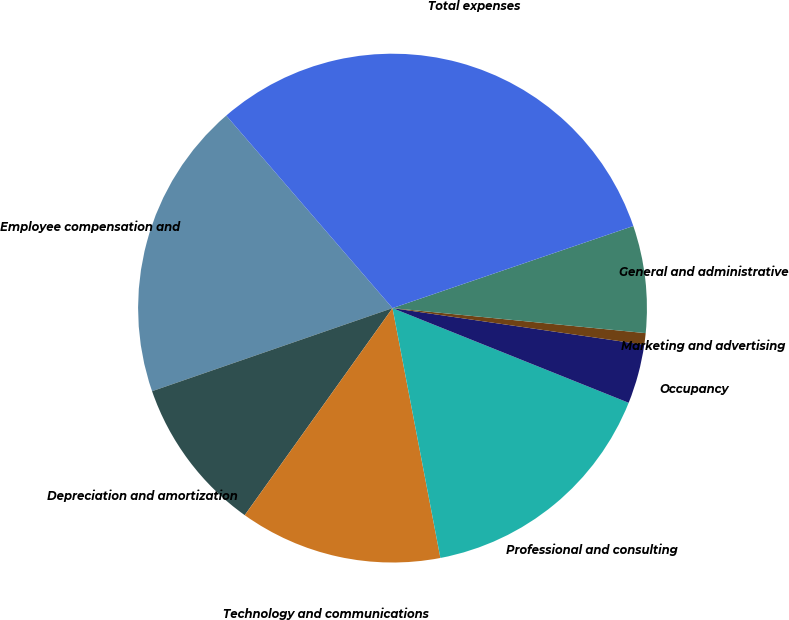Convert chart to OTSL. <chart><loc_0><loc_0><loc_500><loc_500><pie_chart><fcel>Employee compensation and<fcel>Depreciation and amortization<fcel>Technology and communications<fcel>Professional and consulting<fcel>Occupancy<fcel>Marketing and advertising<fcel>General and administrative<fcel>Total expenses<nl><fcel>18.96%<fcel>9.84%<fcel>12.88%<fcel>15.92%<fcel>3.77%<fcel>0.73%<fcel>6.8%<fcel>31.11%<nl></chart> 